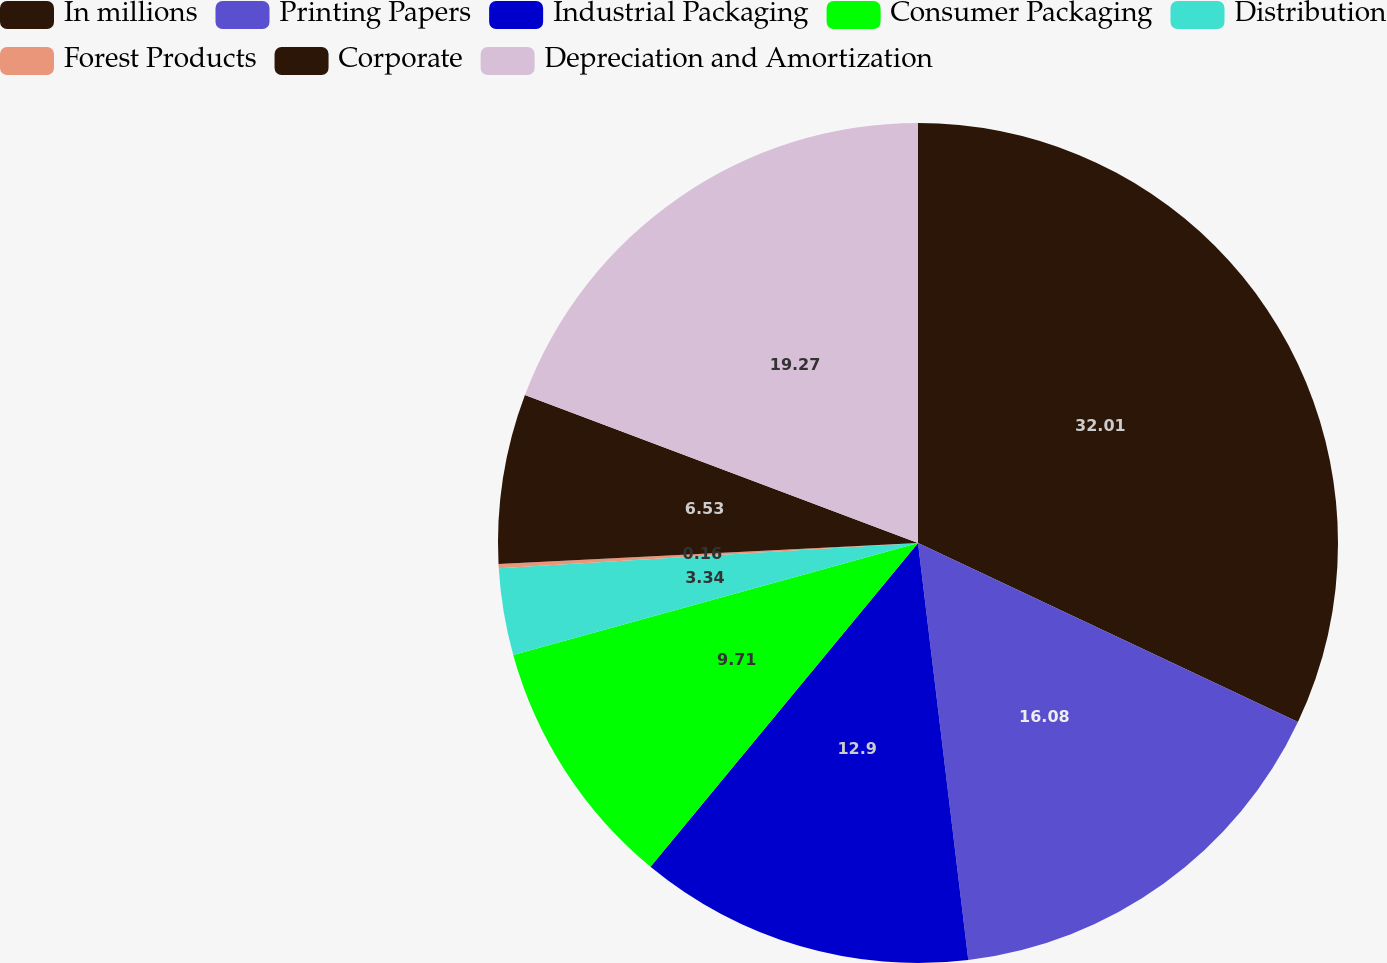<chart> <loc_0><loc_0><loc_500><loc_500><pie_chart><fcel>In millions<fcel>Printing Papers<fcel>Industrial Packaging<fcel>Consumer Packaging<fcel>Distribution<fcel>Forest Products<fcel>Corporate<fcel>Depreciation and Amortization<nl><fcel>32.01%<fcel>16.08%<fcel>12.9%<fcel>9.71%<fcel>3.34%<fcel>0.16%<fcel>6.53%<fcel>19.27%<nl></chart> 